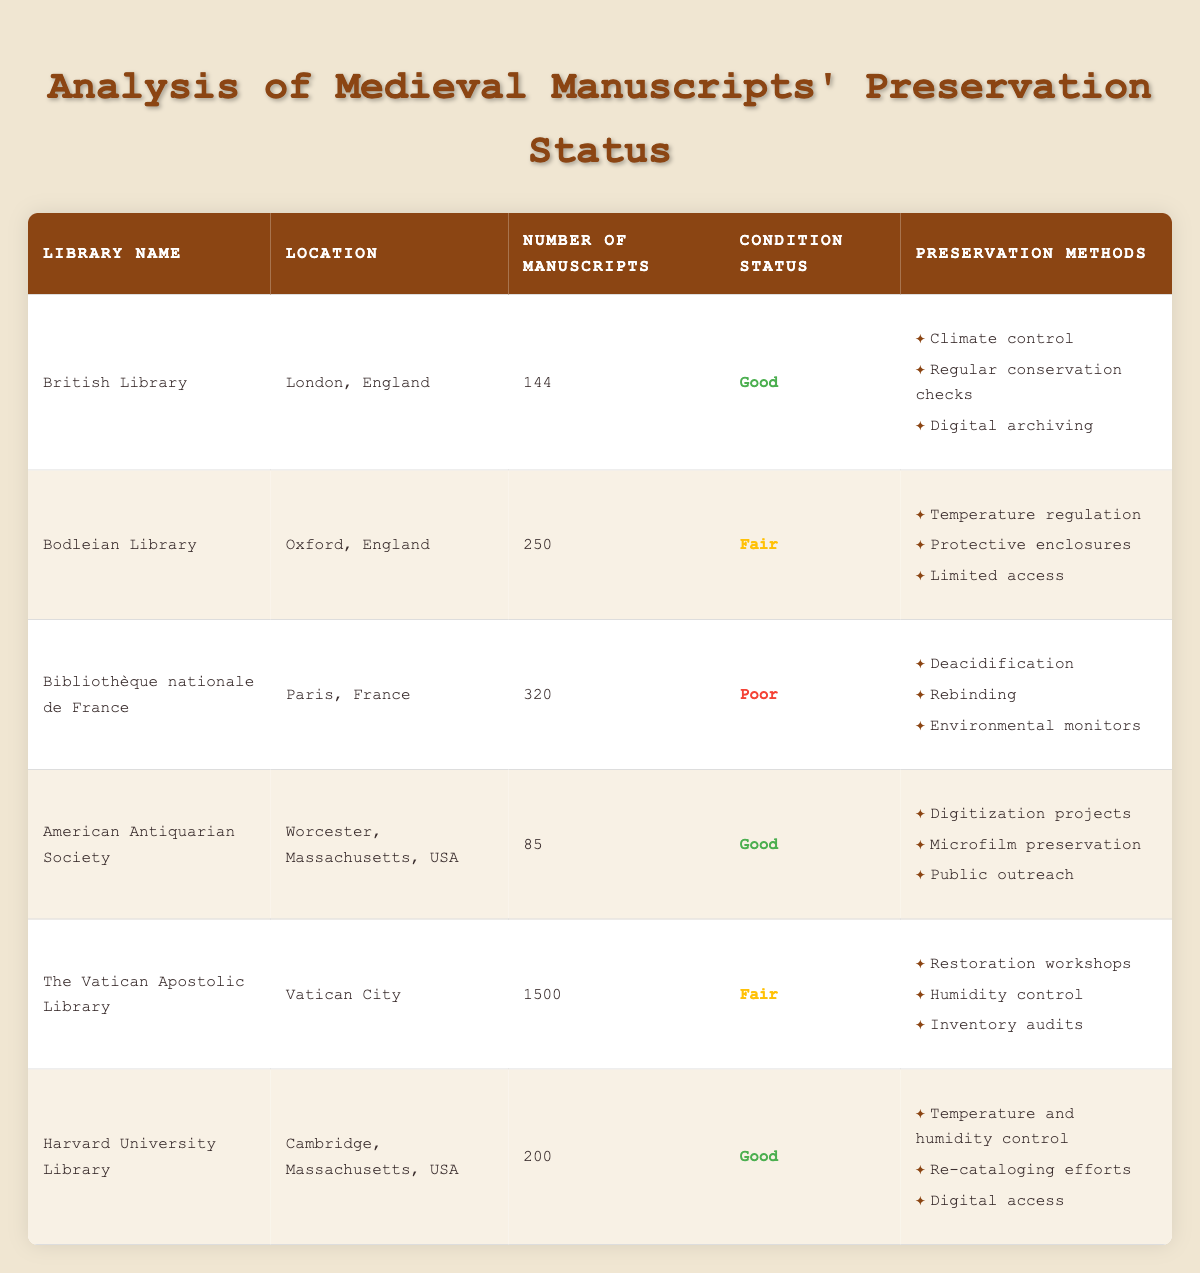What is the condition status of the Bodleian Library? The condition status for the Bodleian Library is listed in the table under the "Condition Status" column, which states "Fair."
Answer: Fair How many manuscripts are preserved at the Bibliothèque nationale de France? The number of manuscripts at the Bibliothèque nationale de France can be found directly in the "Number of Manuscripts" column, showing a total of 320 manuscripts.
Answer: 320 Which library has the highest number of manuscripts and what is their condition status? By examining the "Number of Manuscripts" column, it is clear that the Vatican Apostolic Library has the highest total at 1500 manuscripts. In the "Condition Status" column, it is labeled as "Fair."
Answer: Vatican Apostolic Library, Fair What is the average number of manuscripts preserved in libraries with a "Good" condition status? To find the average, first, identify the libraries with a "Good" condition status: British Library (144), American Antiquarian Society (85), and Harvard University Library (200). Sum of manuscripts is 144 + 85 + 200 = 429. There are 3 libraries, so the average is 429/3 = 143.
Answer: 143 Is the American Antiquarian Society in good condition? Referring to the "Condition Status" column, the American Antiquarian Society is classified as "Good."
Answer: Yes Which preservation method is common to all libraries listed in the table? By analyzing the preservation methods in each library’s row, it can be observed that no single preservation method is repeated across all libraries, meaning there is no common method for all.
Answer: No common method How many libraries have a "Poor" condition status? The "Condition Status" column needs to be examined for any instances listed as "Poor." The only library with this status is the Bibliothèque nationale de France, leading to a total of 1 library.
Answer: 1 Which library located in the USA has a "Fair" condition status? Looking under the "Location" and "Condition Status" columns, only the Vatican Apostolic Library qualifies with a "Fair" status, despite being in the USA. Therefore, no such library exists; the requirement is unmet.
Answer: None What percentage of libraries have a "Good" condition status? Count the libraries with a "Good" condition status: three (British Library, American Antiquarian Society, and Harvard University Library) out of six total libraries. The percentage is (3/6)*100 = 50%.
Answer: 50% 